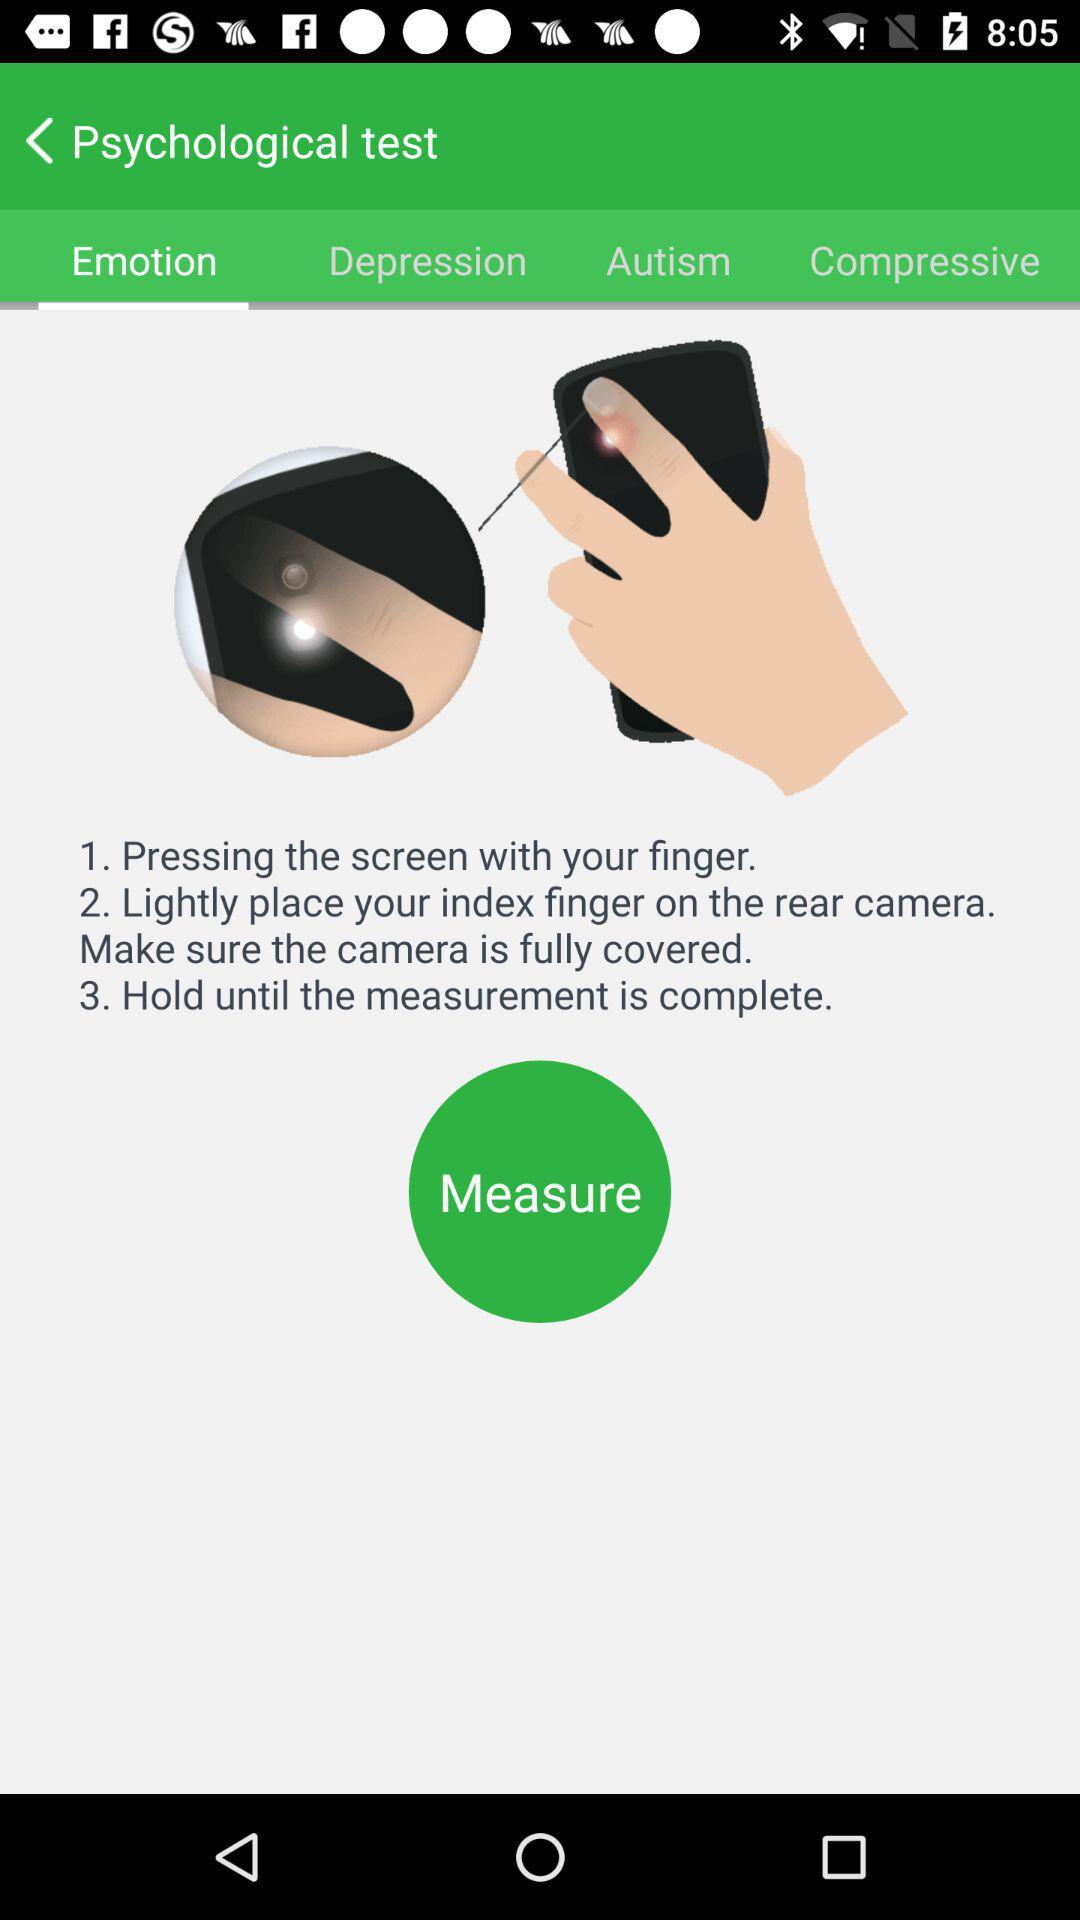How many steps are there in the instructions?
Answer the question using a single word or phrase. 3 